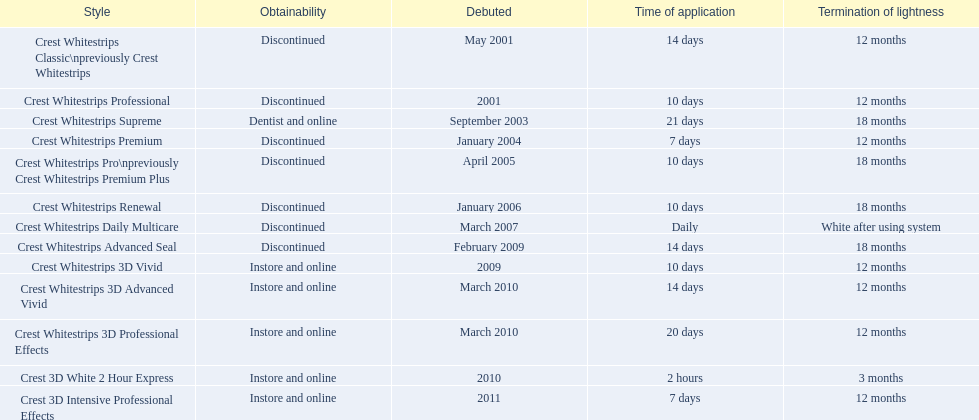What were the models of crest whitestrips? Crest Whitestrips Classic\npreviously Crest Whitestrips, Crest Whitestrips Professional, Crest Whitestrips Supreme, Crest Whitestrips Premium, Crest Whitestrips Pro\npreviously Crest Whitestrips Premium Plus, Crest Whitestrips Renewal, Crest Whitestrips Daily Multicare, Crest Whitestrips Advanced Seal, Crest Whitestrips 3D Vivid, Crest Whitestrips 3D Advanced Vivid, Crest Whitestrips 3D Professional Effects, Crest 3D White 2 Hour Express, Crest 3D Intensive Professional Effects. When were they introduced? May 2001, 2001, September 2003, January 2004, April 2005, January 2006, March 2007, February 2009, 2009, March 2010, March 2010, 2010, 2011. And what is their availability? Discontinued, Discontinued, Dentist and online, Discontinued, Discontinued, Discontinued, Discontinued, Discontinued, Instore and online, Instore and online, Instore and online, Instore and online, Instore and online. Along crest whitestrips 3d vivid, which discontinued model was released in 2009? Crest Whitestrips Advanced Seal. 